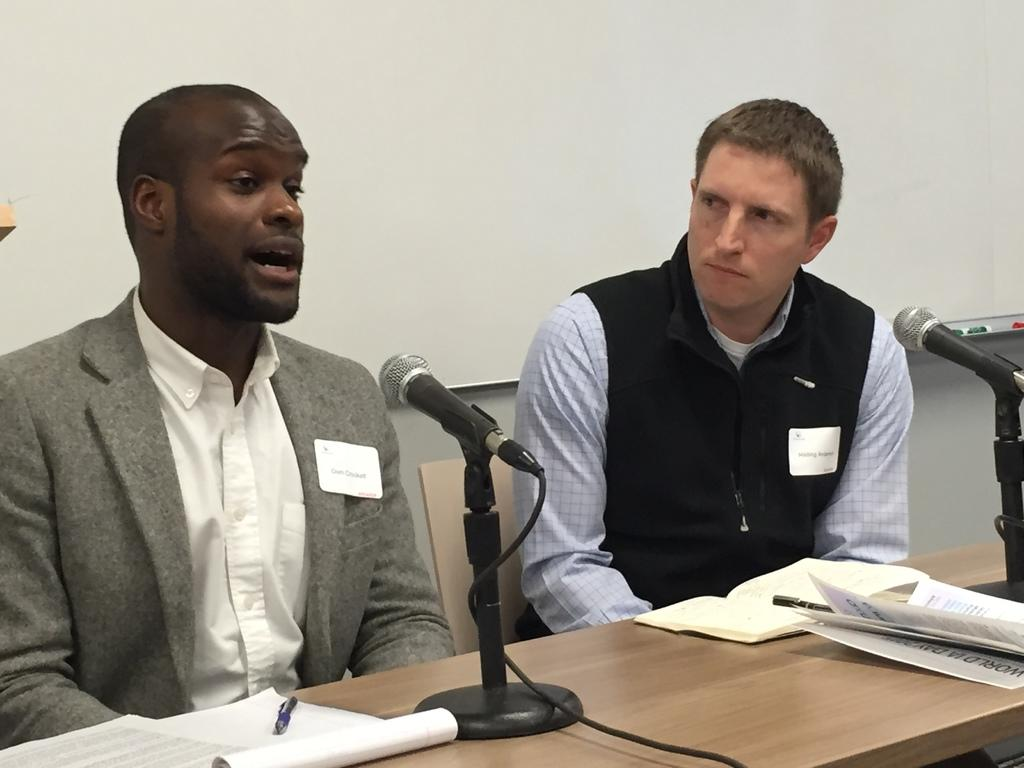How many people are in the image? There are people in the image, but the exact number is not specified. What is the main piece of furniture in the image? There is a table in the image. What items can be seen on the table? There are books, posters, and microphones on the table. What is visible on the wall in the image? There are objects on the wall. Can you describe the object on the left side of the image? There is an object on the left side of the image, but no specific details are provided. How many airplanes are flying in the image? There is no mention of airplanes in the image, so it is not possible to determine their presence or number. What form does the dinosaur on the table take? There is no mention of a dinosaur in the image, so it is not possible to describe its form. 